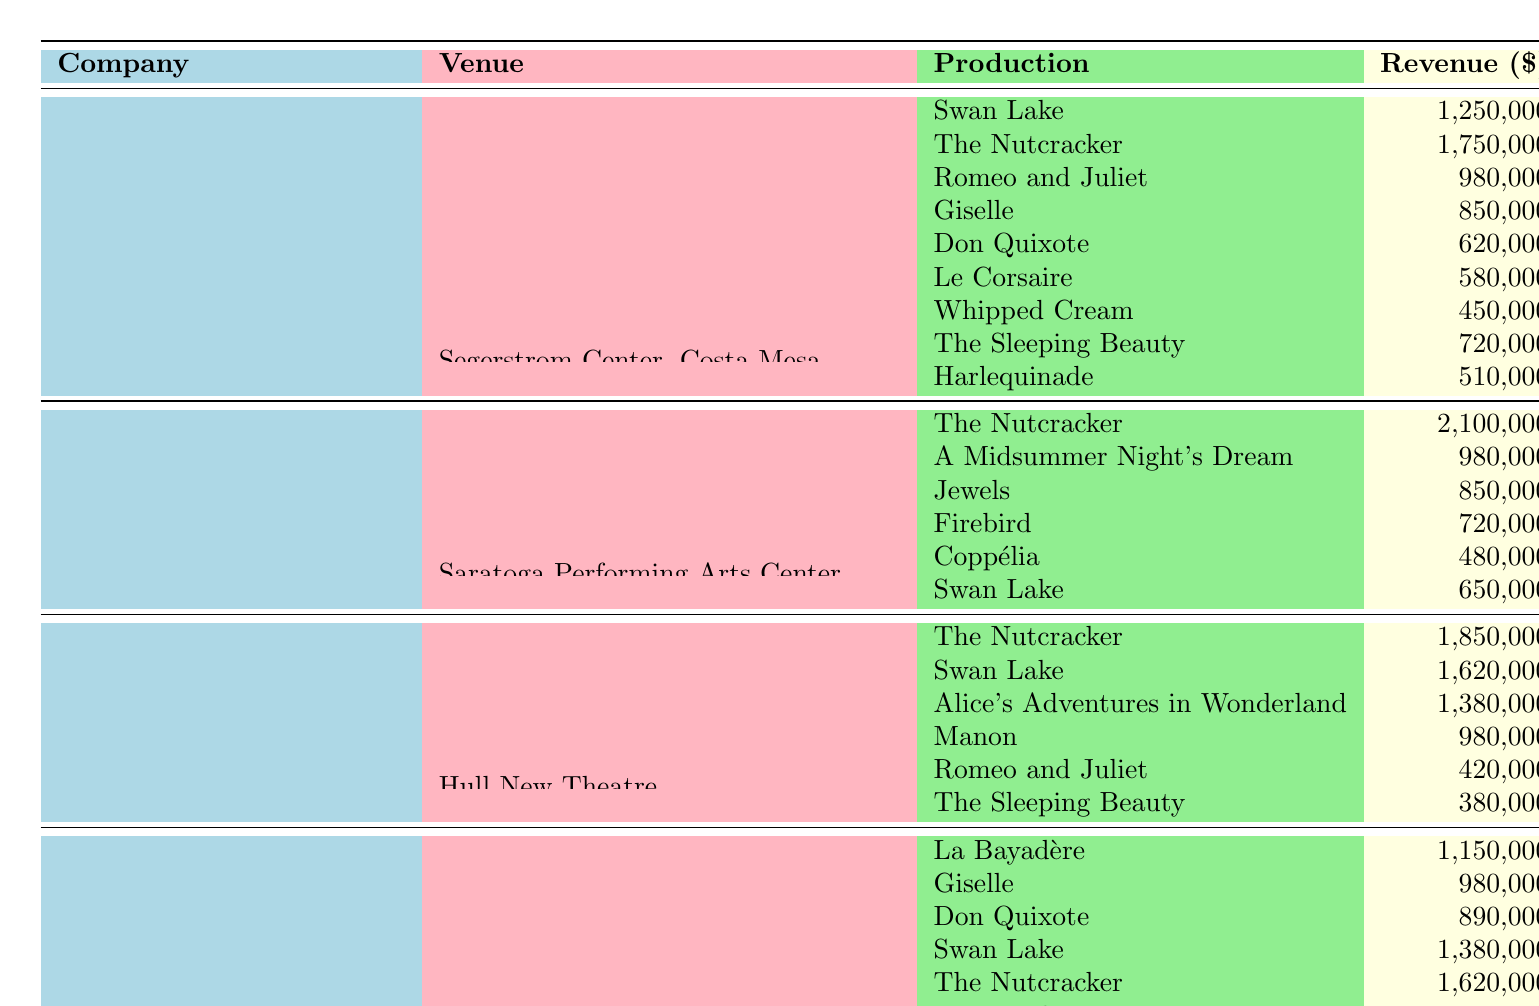What is the total revenue generated by the American Ballet Theatre at the Metropolitan Opera House, New York? To find the total revenue for the American Ballet Theatre at this venue, we sum the revenue of all productions listed: Swan Lake (1,250,000) + The Nutcracker (1,750,000) + Romeo and Juliet (980,000) + Giselle (850,000) = 4,830,000.
Answer: 4,830,000 Which ballet production generated the highest revenue for the New York City Ballet and how much was it? From the table, the highest revenue for the New York City Ballet is from The Nutcracker, which generated 2,100,000.
Answer: The Nutcracker, 2,100,000 Did Royal Ballet perform The Sleeping Beauty at multiple venues? The table shows that The Sleeping Beauty was performed only at Hull New Theatre by the Royal Ballet, meaning it was not performed at multiple venues.
Answer: No What is the revenue difference between the highest and lowest earning productions for the Paris Opera Ballet? The highest earning production for the Paris Opera Ballet is The Nutcracker with 1,620,000, while the lowest is Raymonda at 760,000. The difference is 1,620,000 - 760,000 = 860,000.
Answer: 860,000 Which venue generated the least total revenue for the American Ballet Theatre? The total revenues for its venues are as follows: Metropolitan Opera House (4,830,000), Kennedy Center (1,650,000), and Segerstrom Center (1,230,000). The Segerstrom Center has the least revenue with 1,230,000.
Answer: Segerstrom Center, 1,230,000 What is the average revenue per production for the Royal Ballet? The Royal Ballet has 6 productions with revenues listed, which are: The Nutcracker (1,850,000), Swan Lake (1,620,000), Alice's Adventures in Wonderland (1,380,000), Manon (980,000), Romeo and Juliet (420,000), and The Sleeping Beauty (380,000). Their total revenue is 6,630,000. Dividing by the number of productions (6), the average revenue is 6,630,000 / 6 = 1,105,000.
Answer: 1,105,000 What was the total revenue from ballets performed at the Palais Garnier? The productions at Palais Garnier include La Bayadère (1,150,000), Giselle (980,000), and Don Quixote (890,000). Adding these revenues gives 1,150,000 + 980,000 + 890,000 = 3,020,000.
Answer: 3,020,000 Is The Nutcracker the most profitable ballet for both the New York City Ballet and Royal Ballet? The Nutcracker is indeed the highest earning for the New York City Ballet with 2,100,000, but for the Royal Ballet, it earned 1,850,000, which is less than Swan Lake’s 1,620,000. Therefore, it is not the most profitable for both.
Answer: No How does the average revenue of the productions at the Opéra Bastille compare to that of the Royal Opera House? The Opéra Bastille has three productions, totaling 1,380,000 + 1,620,000 + 760,000 = 3,760,000. Thus, the average revenue is 3,760,000 / 3 = 1,253,333. The Royal Opera House total is 5,830,000 with an average of 5,830,000 / 4 = 1,457,500. Since 1,253,333 < 1,457,500, the Opéra Bastille's average revenue is less.
Answer: Opéra Bastille has less average revenue 